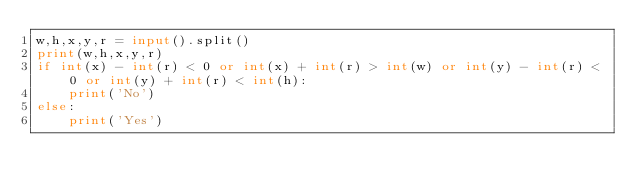Convert code to text. <code><loc_0><loc_0><loc_500><loc_500><_Python_>w,h,x,y,r = input().split()
print(w,h,x,y,r)
if int(x) - int(r) < 0 or int(x) + int(r) > int(w) or int(y) - int(r) < 0 or int(y) + int(r) < int(h):
    print('No')
else:
    print('Yes')</code> 